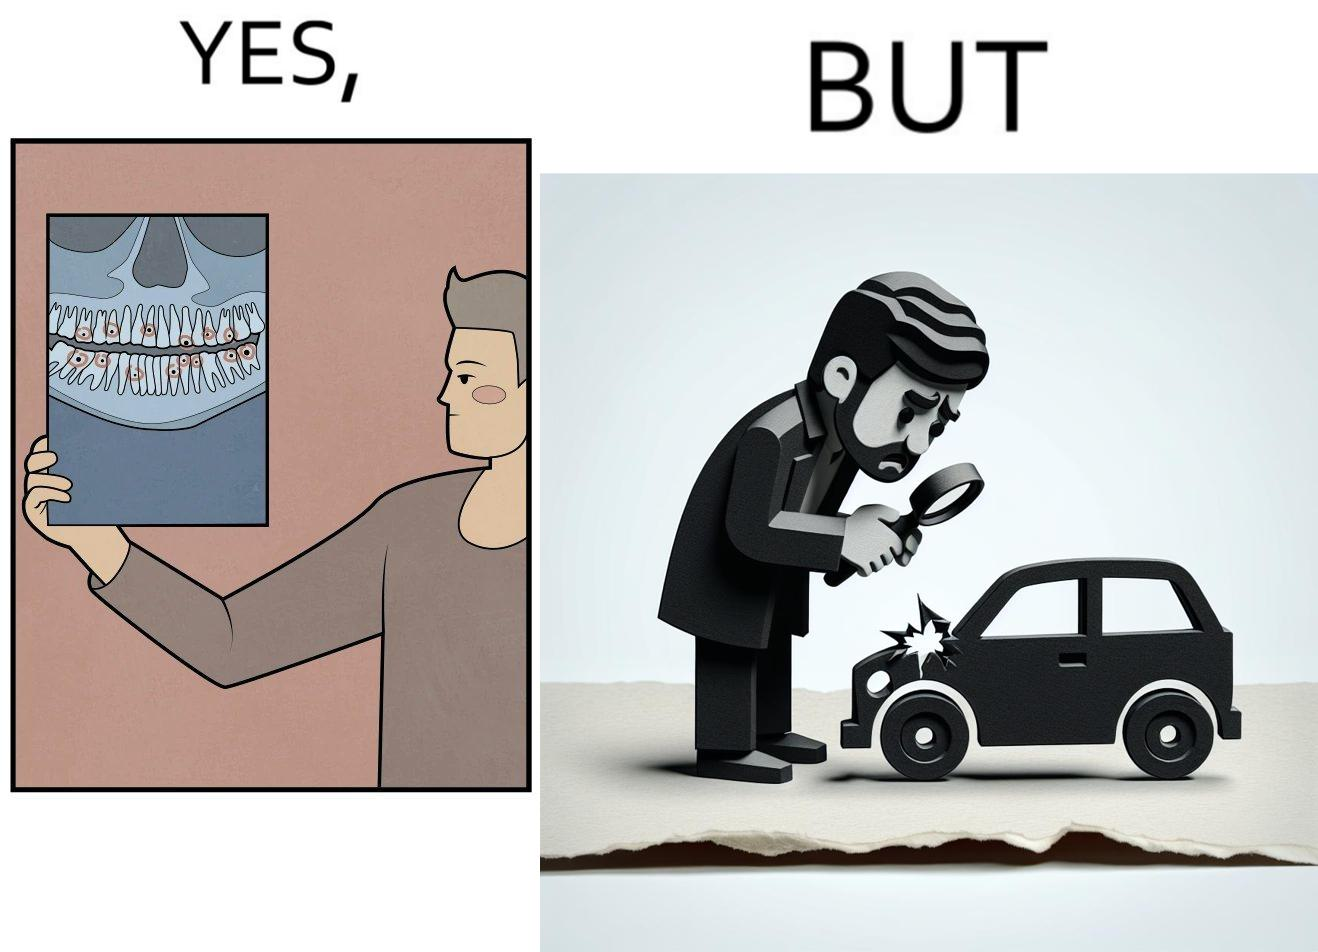What makes this image funny or satirical? The images are funny since they show how people are more worried about small damages to  things they can replace like cars but are not worried about permanent damages to their own health 